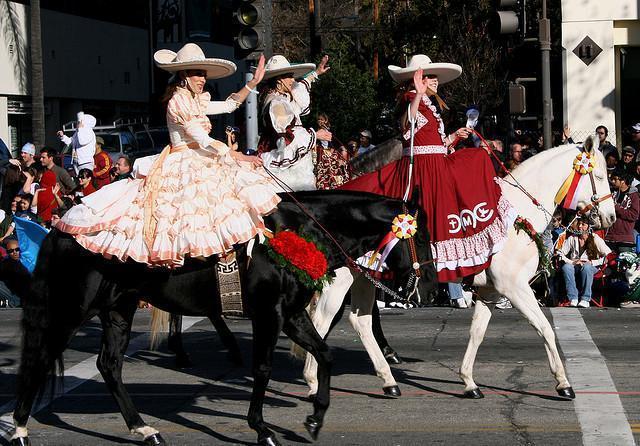What color is the woman's dress who is riding a white stallion?
Select the accurate answer and provide justification: `Answer: choice
Rationale: srationale.`
Options: Yellow, pink, green, red. Answer: red.
Rationale: The dress is red. 